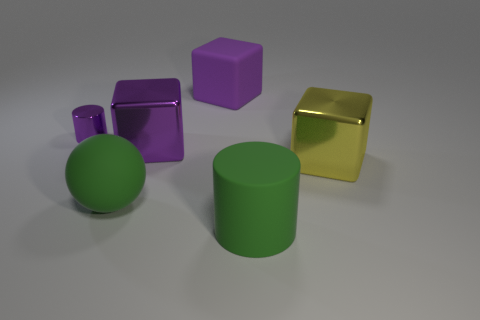How many other things are there of the same color as the small shiny cylinder?
Your answer should be compact. 2. What is the color of the shiny cylinder that is behind the yellow cube?
Give a very brief answer. Purple. Are there any matte blocks of the same size as the purple metal cylinder?
Offer a very short reply. No. There is a green cylinder that is the same size as the yellow cube; what is its material?
Ensure brevity in your answer.  Rubber. What number of things are metal blocks on the right side of the big green cylinder or purple objects to the right of the tiny shiny cylinder?
Your response must be concise. 3. Are there any other large matte things that have the same shape as the big yellow thing?
Your response must be concise. Yes. There is another big cube that is the same color as the matte block; what is it made of?
Provide a short and direct response. Metal. What number of shiny objects are either big cylinders or large yellow things?
Your response must be concise. 1. The tiny shiny thing is what shape?
Give a very brief answer. Cylinder. How many green objects have the same material as the sphere?
Make the answer very short. 1. 